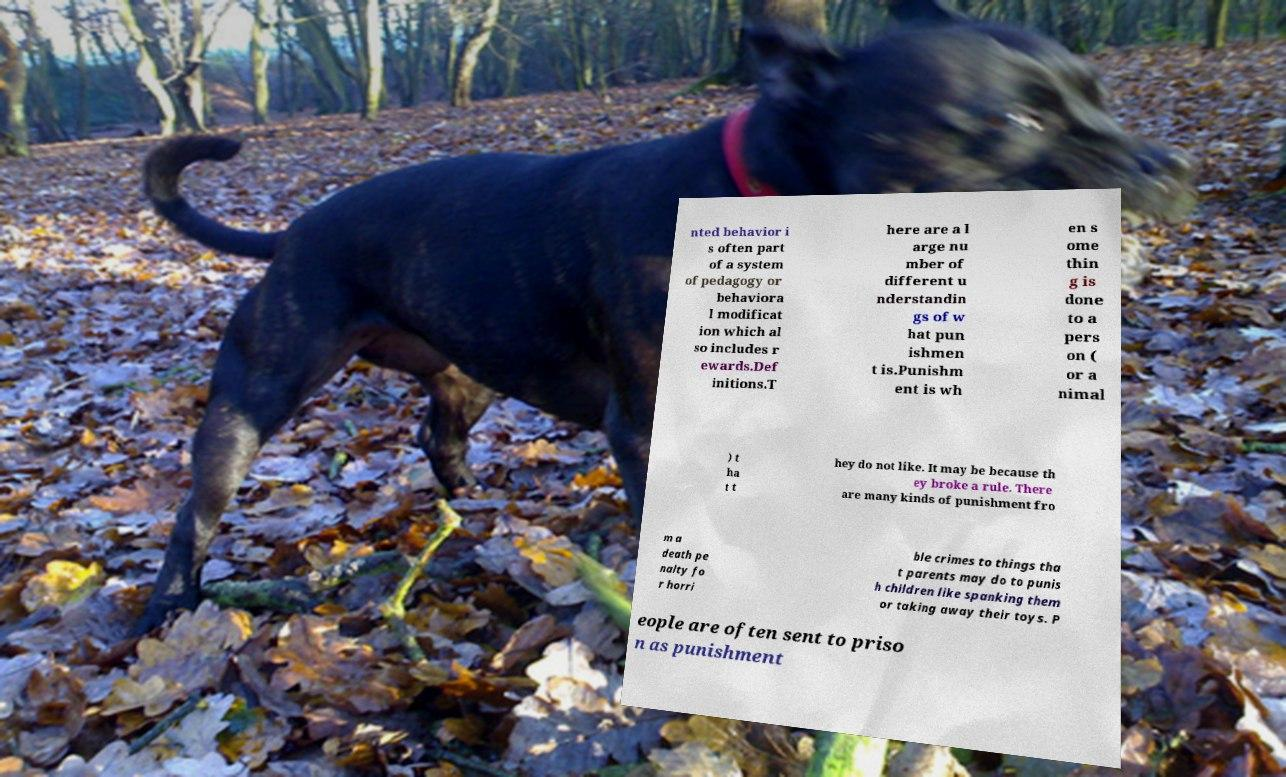Please read and relay the text visible in this image. What does it say? nted behavior i s often part of a system of pedagogy or behaviora l modificat ion which al so includes r ewards.Def initions.T here are a l arge nu mber of different u nderstandin gs of w hat pun ishmen t is.Punishm ent is wh en s ome thin g is done to a pers on ( or a nimal ) t ha t t hey do not like. It may be because th ey broke a rule. There are many kinds of punishment fro m a death pe nalty fo r horri ble crimes to things tha t parents may do to punis h children like spanking them or taking away their toys. P eople are often sent to priso n as punishment 